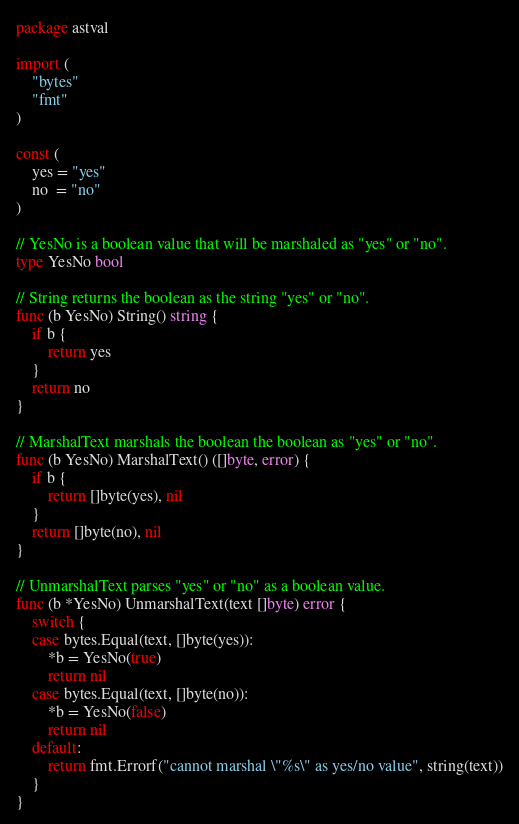<code> <loc_0><loc_0><loc_500><loc_500><_Go_>package astval

import (
	"bytes"
	"fmt"
)

const (
	yes = "yes"
	no  = "no"
)

// YesNo is a boolean value that will be marshaled as "yes" or "no".
type YesNo bool

// String returns the boolean as the string "yes" or "no".
func (b YesNo) String() string {
	if b {
		return yes
	}
	return no
}

// MarshalText marshals the boolean the boolean as "yes" or "no".
func (b YesNo) MarshalText() ([]byte, error) {
	if b {
		return []byte(yes), nil
	}
	return []byte(no), nil
}

// UnmarshalText parses "yes" or "no" as a boolean value.
func (b *YesNo) UnmarshalText(text []byte) error {
	switch {
	case bytes.Equal(text, []byte(yes)):
		*b = YesNo(true)
		return nil
	case bytes.Equal(text, []byte(no)):
		*b = YesNo(false)
		return nil
	default:
		return fmt.Errorf("cannot marshal \"%s\" as yes/no value", string(text))
	}
}
</code> 